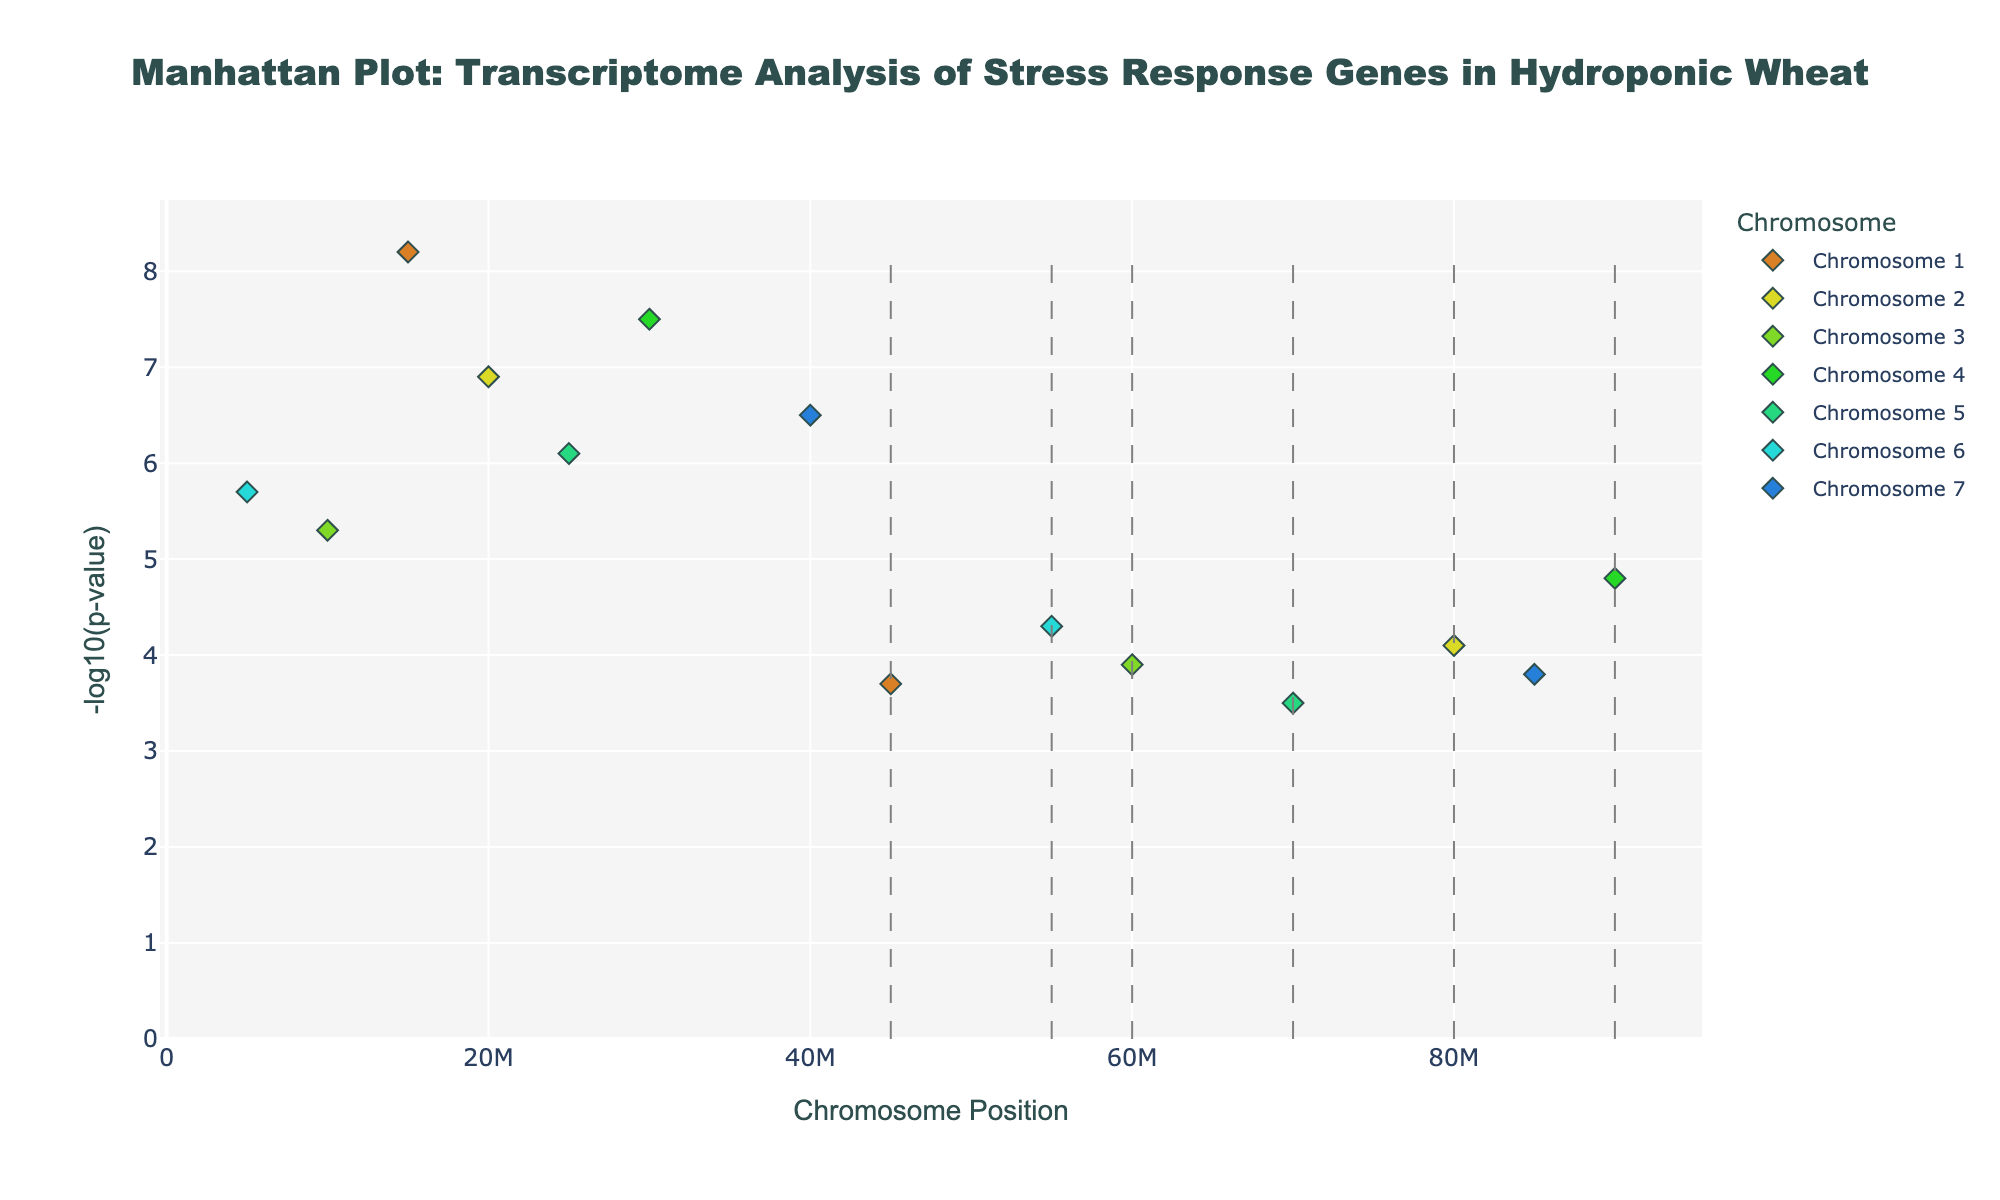What is the title of the plot? The title is located at the top center of the plot and typically provides a concise description of the chart's content. Here, the title reads "Manhattan Plot: Transcriptome Analysis of Stress Response Genes in Hydroponic Wheat."
Answer: Manhattan Plot: Transcriptome Analysis of Stress Response Genes in Hydroponic Wheat Which chromosome has the highest -log10(p-value) and what is the value? By scanning the visual plot, we can look for the highest peak among all chromosomes. Chromosome 1 has the highest -log10(p-value) with a value of 8.2.
Answer: Chromosome 1, 8.2 What gene is represented by the highest point on the plot? The highest point on the Manhattan plot corresponds to the largest -log10(p-value) value. The gene associated with this point is displayed upon hovering over it. This is TaHKT1;5 on Chromosome 1.
Answer: TaHKT1;5 How many genes have a -log10(p-value) greater than 6.0? Visually identify and count the points above the y-axis value of 6.0. There are four such points. The genes are TaHKT1;5, TaSOS1, TaVP1, and TaNHX4.
Answer: 4 Which chromosome has the most genes represented on the plot? Examine each chromosome section to count the number of points related to each chromosome. Chromosome 5 has the most genes represented, with a total of two points.
Answer: Chromosome 5 On which chromosome can we find the gene TaNHX3? Locate the gene TaNHX3 by either searching through the plotted points or identifying it by its position within the chromosomal annotations. TaNHX3 is found on Chromosome 5.
Answer: Chromosome 5 Compare the -log10(p-value) of TaSOS1 and TaNHX4. Which gene has the higher value and by how much? Find the values of -log10(p-value) for TaSOS1 (6.9) and TaNHX4 (6.5), then subtract the smaller value from the larger value. TaSOS1 has a higher value by 0.4.
Answer: TaSOS1, 0.4 What is the average -log10(p-value) of the genes on Chromosome 2? The values for Chromosome 2 are 6.9 (TaSOS1) and 4.1 (TaAKT1). Calculate the average by summing them (6.9 + 4.1 = 11.0) and dividing by the number of points (2). The average is 11.0 / 2 = 5.5.
Answer: 5.5 